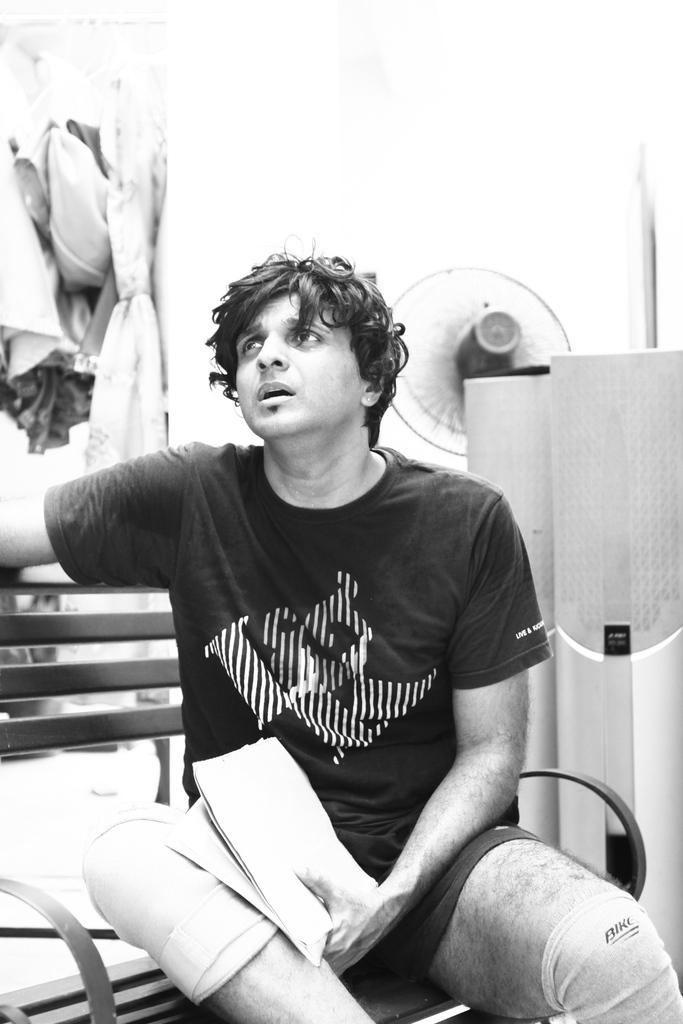What is the main subject in the foreground of the image? There is a person in the foreground of the image. What is the person doing in the image? The person is sitting on a bench. What is the person holding in their left hand? The person is holding something in their left hand, but the specific object is not mentioned in the facts. Can you see a bean growing on the person's head in the image? No, there is no bean growing on the person's head in the image. 